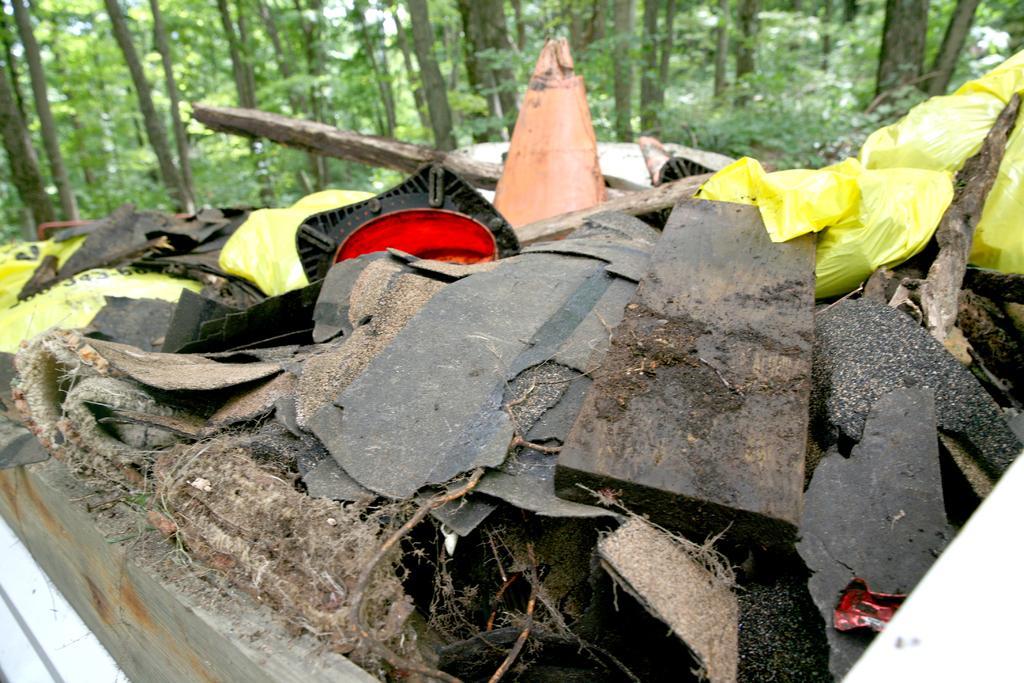Could you give a brief overview of what you see in this image? In this picture I can see there is a garbage here and there are trees in the backdrop. 